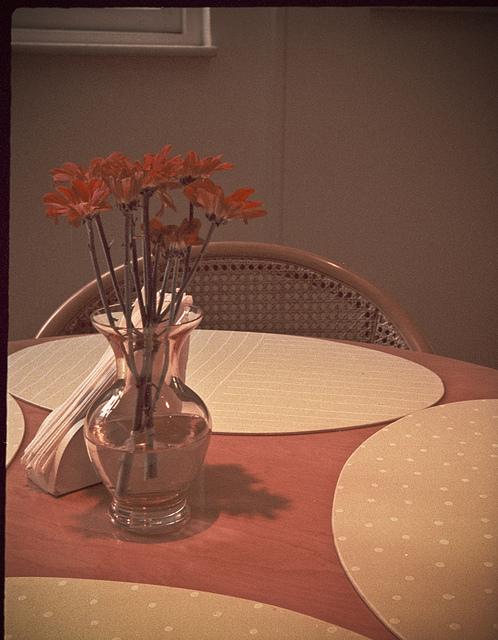What pattern is shown on the mats?
Be succinct. Polka dots. Are the flowers fresh or fake?
Be succinct. Fresh. Are the patterns of the placemats all the same?
Short answer required. No. 